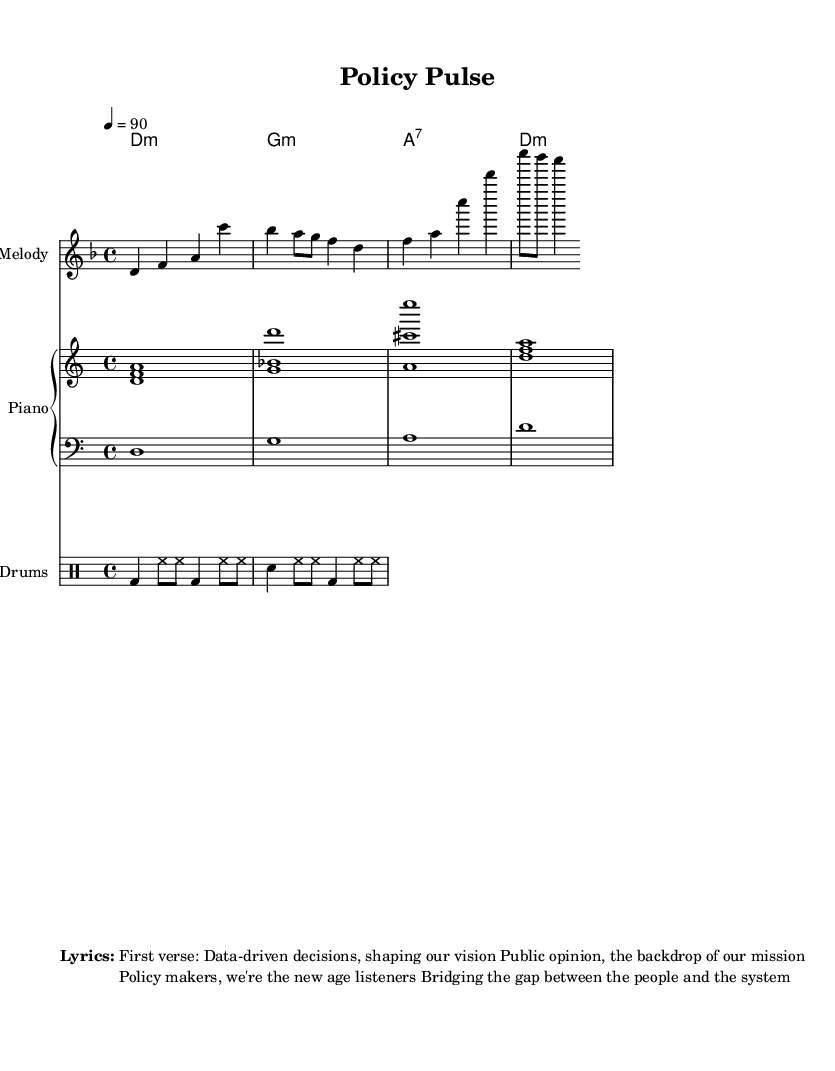What is the key signature of this music? The key signature shown is D minor, indicated by the presence of one flat (B flat) in the signature area.
Answer: D minor What is the time signature of the piece? The time signature is shown at the beginning of the score, represented by the fraction 4 over 4, which denotes four beats per measure.
Answer: 4/4 What is the tempo marking for this piece? The tempo is indicated as "4 = 90," meaning there are 90 beats per minute, with the quarter note representing one beat.
Answer: 90 How many measures are in the melody section? By counting the groups of notes, there are four measures in the melody section, each containing varied note lengths while fitting within the 4/4 time signature.
Answer: 4 What chord is played in the first measure of the harmonies? The first measure features a D minor chord, as denoted by the chord symbol "d:m" placed aligned above the measures where it occurs.
Answer: D minor Which instrument is providing the bassline? The bassline is played by a clef labeled "bass," which is usually associated with lower-pitched instruments such as the bass guitar or double bass in this arrangement.
Answer: Bass What is the primary theme of the lyrics? The lyrics focus on themes of data-driven decisions and the relationship between public opinion and policy-making, addressing the connection between citizens and their government.
Answer: Data-driven decisions 